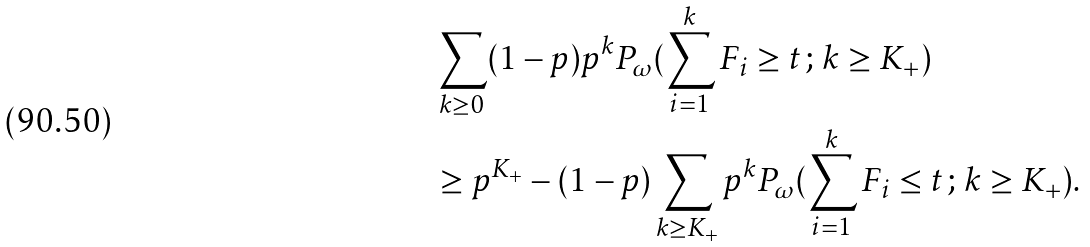<formula> <loc_0><loc_0><loc_500><loc_500>& \sum _ { k \geq 0 } ( 1 - p ) p ^ { k } P _ { \omega } ( \sum _ { i = 1 } ^ { k } F _ { i } \geq t \, ; \, k \geq K _ { + } ) \\ & \geq p ^ { K _ { + } } - ( 1 - p ) \sum _ { k \geq K _ { + } } p ^ { k } P _ { \omega } ( \sum _ { i = 1 } ^ { k } F _ { i } \leq t \, ; \, k \geq K _ { + } ) .</formula> 